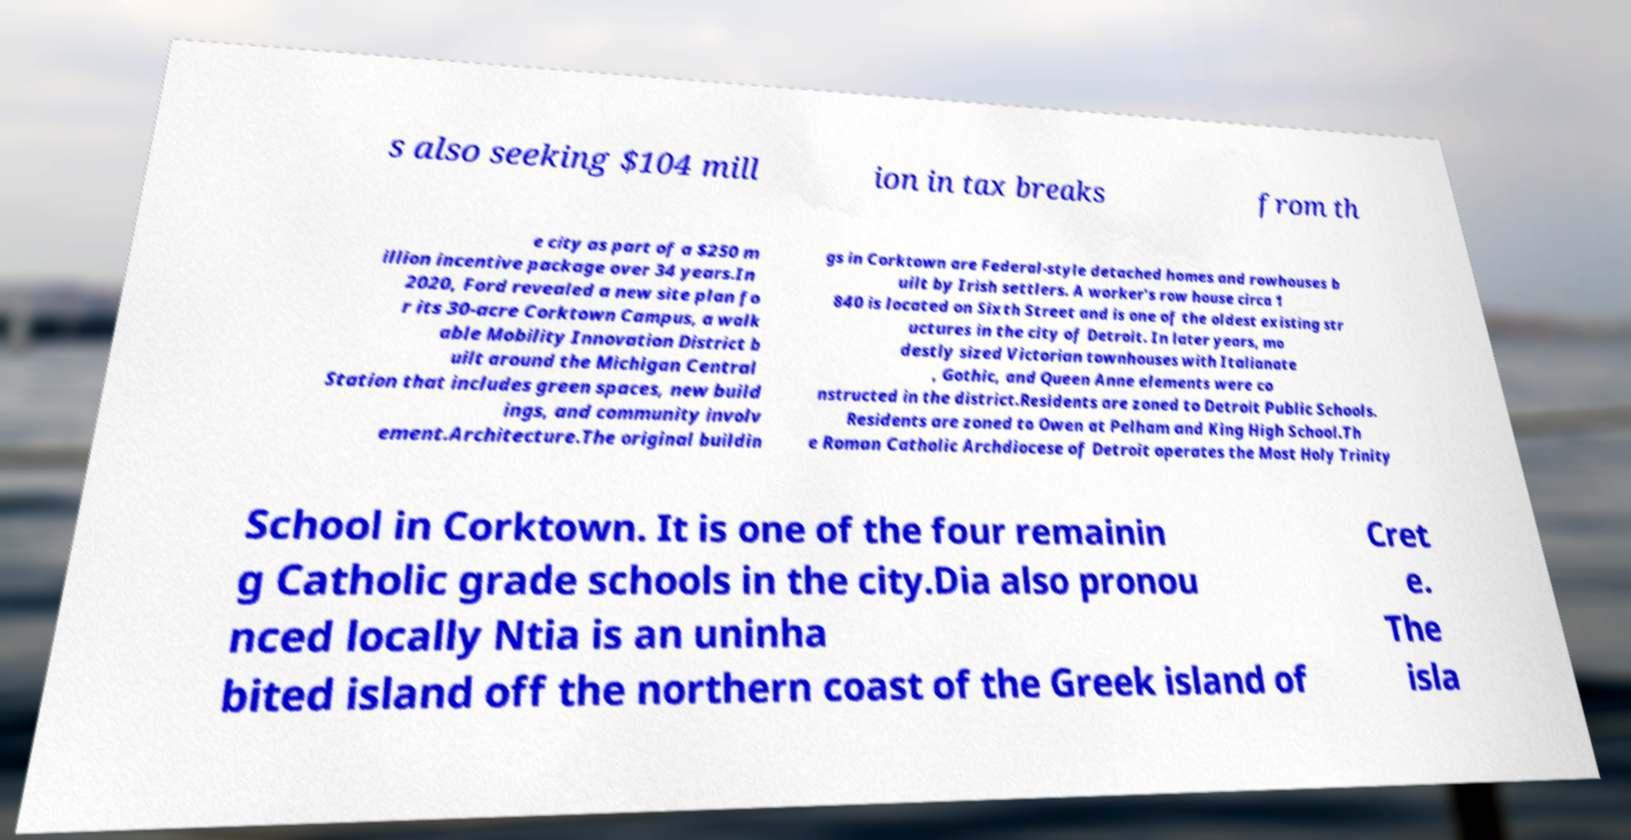Please identify and transcribe the text found in this image. s also seeking $104 mill ion in tax breaks from th e city as part of a $250 m illion incentive package over 34 years.In 2020, Ford revealed a new site plan fo r its 30-acre Corktown Campus, a walk able Mobility Innovation District b uilt around the Michigan Central Station that includes green spaces, new build ings, and community involv ement.Architecture.The original buildin gs in Corktown are Federal-style detached homes and rowhouses b uilt by Irish settlers. A worker's row house circa 1 840 is located on Sixth Street and is one of the oldest existing str uctures in the city of Detroit. In later years, mo destly sized Victorian townhouses with Italianate , Gothic, and Queen Anne elements were co nstructed in the district.Residents are zoned to Detroit Public Schools. Residents are zoned to Owen at Pelham and King High School.Th e Roman Catholic Archdiocese of Detroit operates the Most Holy Trinity School in Corktown. It is one of the four remainin g Catholic grade schools in the city.Dia also pronou nced locally Ntia is an uninha bited island off the northern coast of the Greek island of Cret e. The isla 